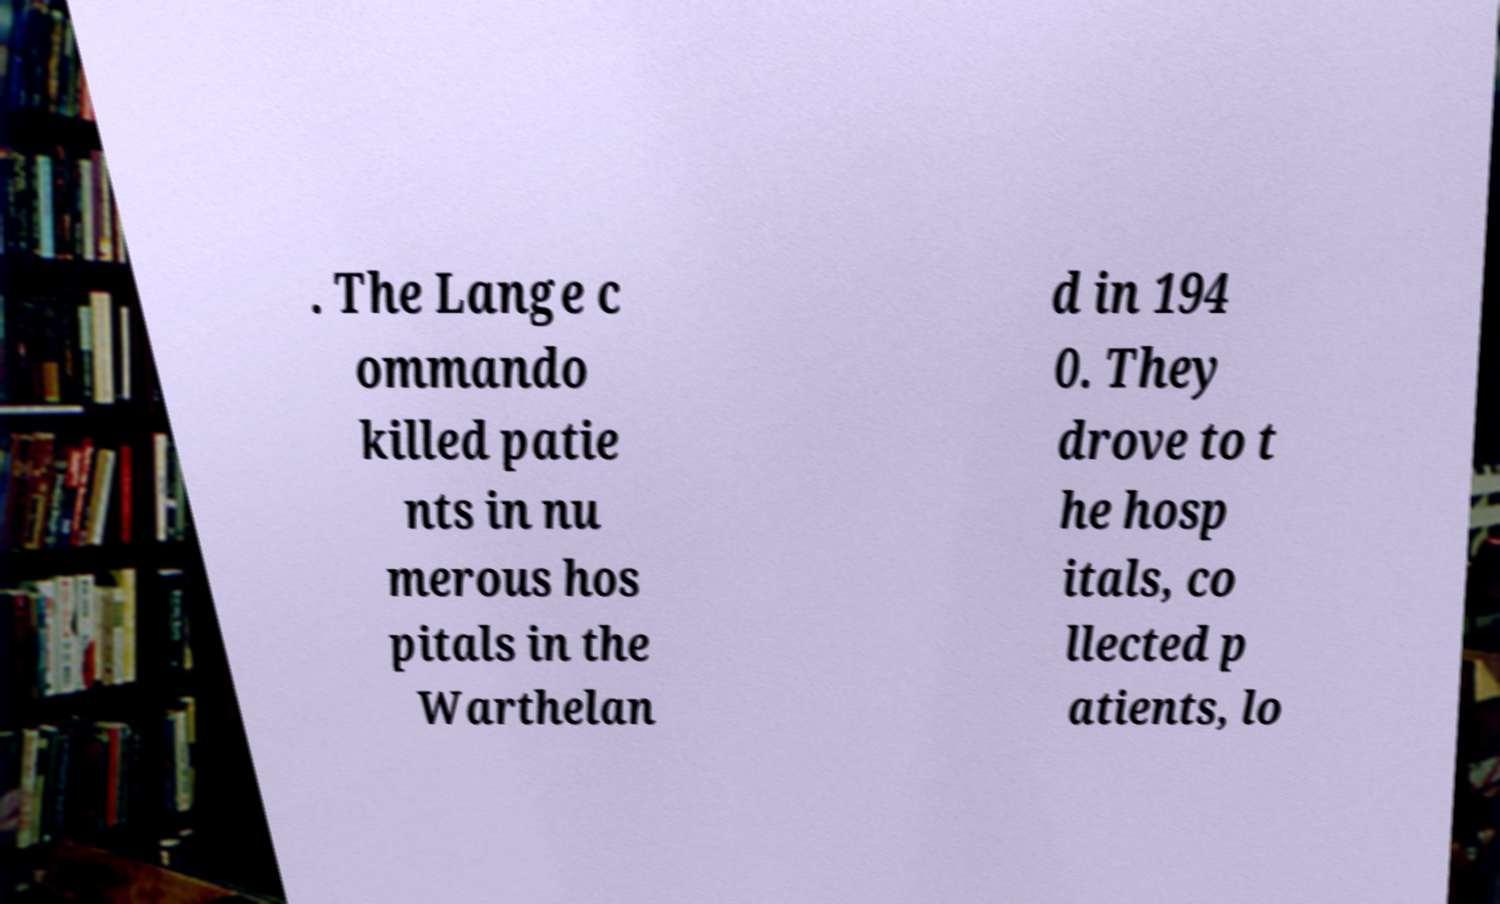Can you read and provide the text displayed in the image?This photo seems to have some interesting text. Can you extract and type it out for me? . The Lange c ommando killed patie nts in nu merous hos pitals in the Warthelan d in 194 0. They drove to t he hosp itals, co llected p atients, lo 